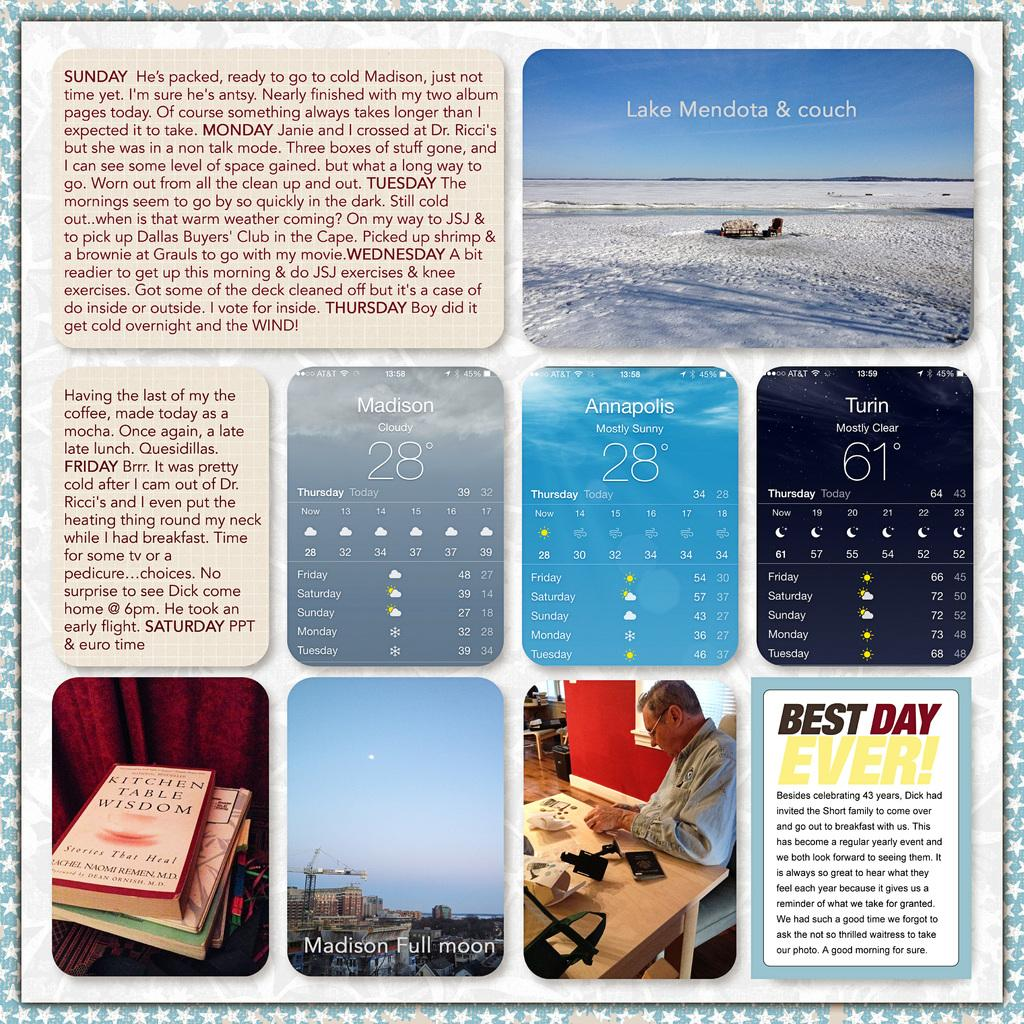<image>
Present a compact description of the photo's key features. A few signs and one that has the best day ever written on it 